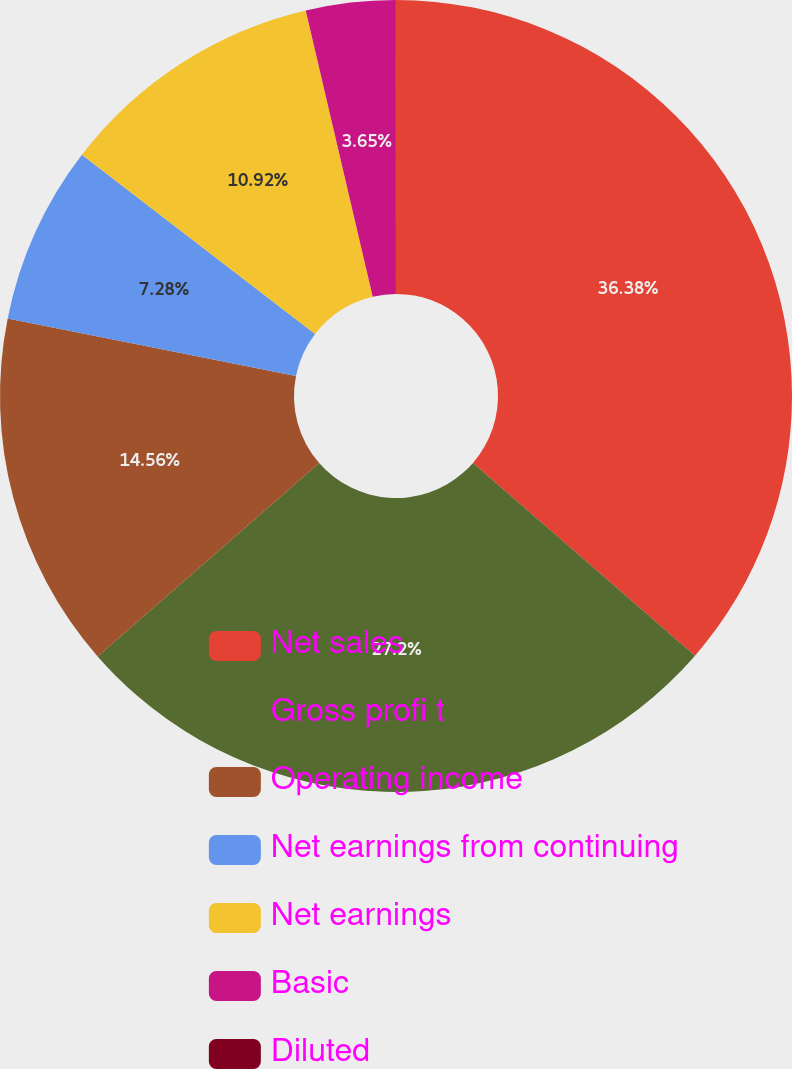Convert chart to OTSL. <chart><loc_0><loc_0><loc_500><loc_500><pie_chart><fcel>Net sales<fcel>Gross profi t<fcel>Operating income<fcel>Net earnings from continuing<fcel>Net earnings<fcel>Basic<fcel>Diluted<nl><fcel>36.38%<fcel>27.2%<fcel>14.56%<fcel>7.28%<fcel>10.92%<fcel>3.65%<fcel>0.01%<nl></chart> 